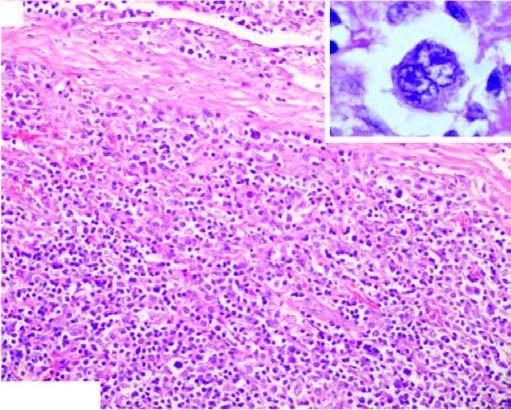what are there?
Answer the question using a single word or phrase. Bands of collagen forming nodules and characteristic lacunar rs cells (inbox in left figure) 